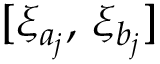Convert formula to latex. <formula><loc_0><loc_0><loc_500><loc_500>[ \xi _ { a _ { j } } , \, \xi _ { b _ { j } } ]</formula> 